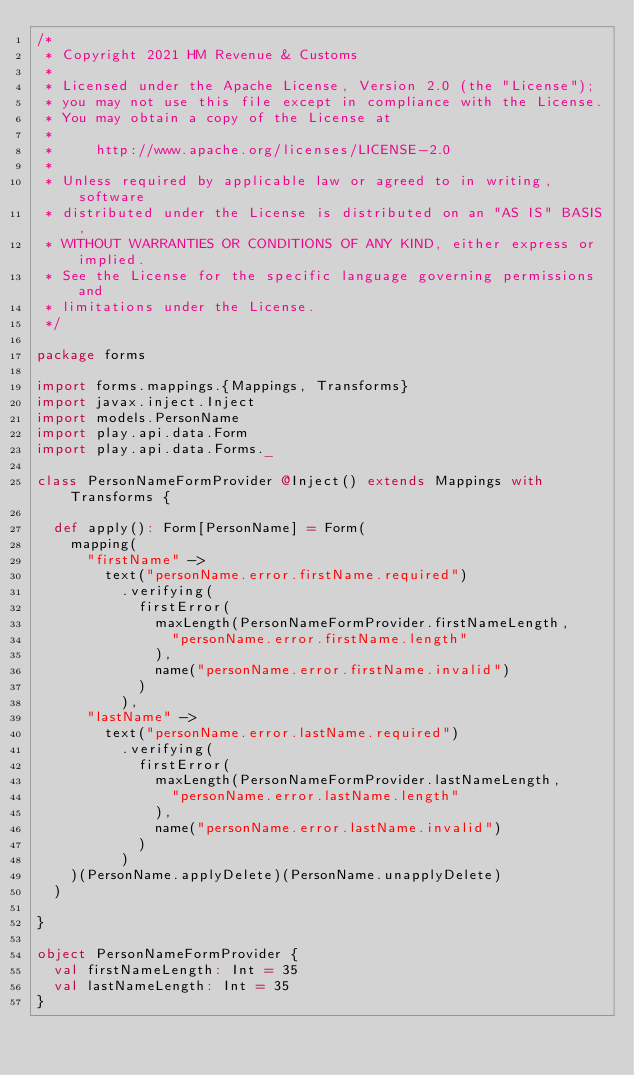<code> <loc_0><loc_0><loc_500><loc_500><_Scala_>/*
 * Copyright 2021 HM Revenue & Customs
 *
 * Licensed under the Apache License, Version 2.0 (the "License");
 * you may not use this file except in compliance with the License.
 * You may obtain a copy of the License at
 *
 *     http://www.apache.org/licenses/LICENSE-2.0
 *
 * Unless required by applicable law or agreed to in writing, software
 * distributed under the License is distributed on an "AS IS" BASIS,
 * WITHOUT WARRANTIES OR CONDITIONS OF ANY KIND, either express or implied.
 * See the License for the specific language governing permissions and
 * limitations under the License.
 */

package forms

import forms.mappings.{Mappings, Transforms}
import javax.inject.Inject
import models.PersonName
import play.api.data.Form
import play.api.data.Forms._

class PersonNameFormProvider @Inject() extends Mappings with Transforms {

  def apply(): Form[PersonName] = Form(
    mapping(
      "firstName" ->
        text("personName.error.firstName.required")
          .verifying(
            firstError(
              maxLength(PersonNameFormProvider.firstNameLength,
                "personName.error.firstName.length"
              ),
              name("personName.error.firstName.invalid")
            )
          ),
      "lastName" ->
        text("personName.error.lastName.required")
          .verifying(
            firstError(
              maxLength(PersonNameFormProvider.lastNameLength,
                "personName.error.lastName.length"
              ),
              name("personName.error.lastName.invalid")
            )
          )
    )(PersonName.applyDelete)(PersonName.unapplyDelete)
  )

}

object PersonNameFormProvider {
  val firstNameLength: Int = 35
  val lastNameLength: Int = 35
}

</code> 